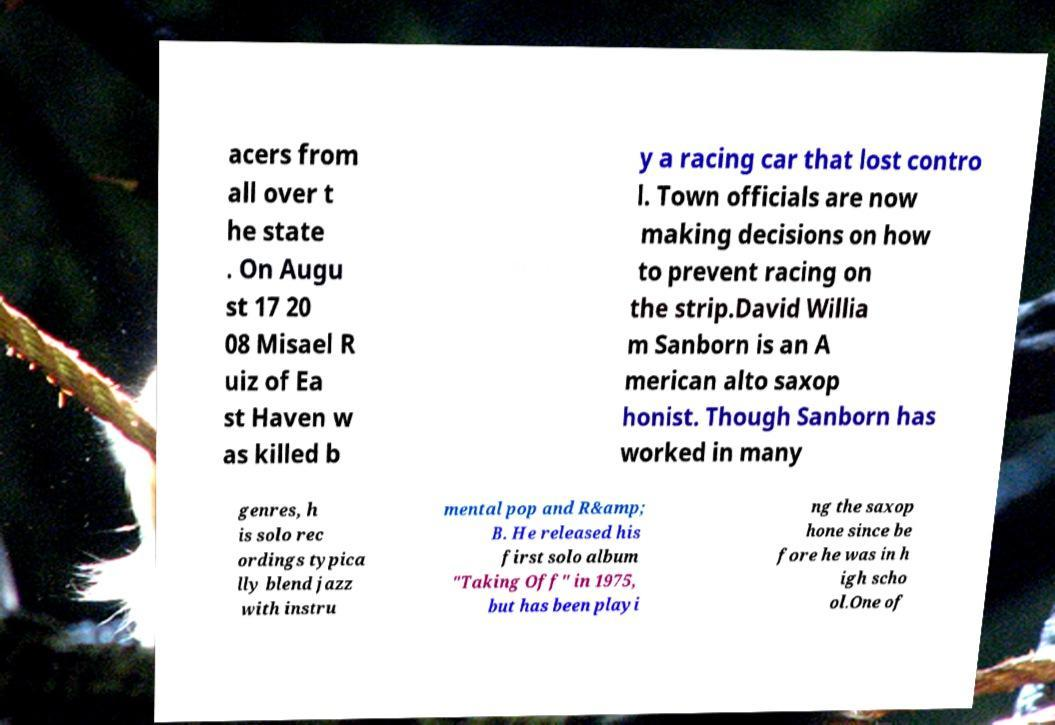Please identify and transcribe the text found in this image. acers from all over t he state . On Augu st 17 20 08 Misael R uiz of Ea st Haven w as killed b y a racing car that lost contro l. Town officials are now making decisions on how to prevent racing on the strip.David Willia m Sanborn is an A merican alto saxop honist. Though Sanborn has worked in many genres, h is solo rec ordings typica lly blend jazz with instru mental pop and R&amp; B. He released his first solo album "Taking Off" in 1975, but has been playi ng the saxop hone since be fore he was in h igh scho ol.One of 